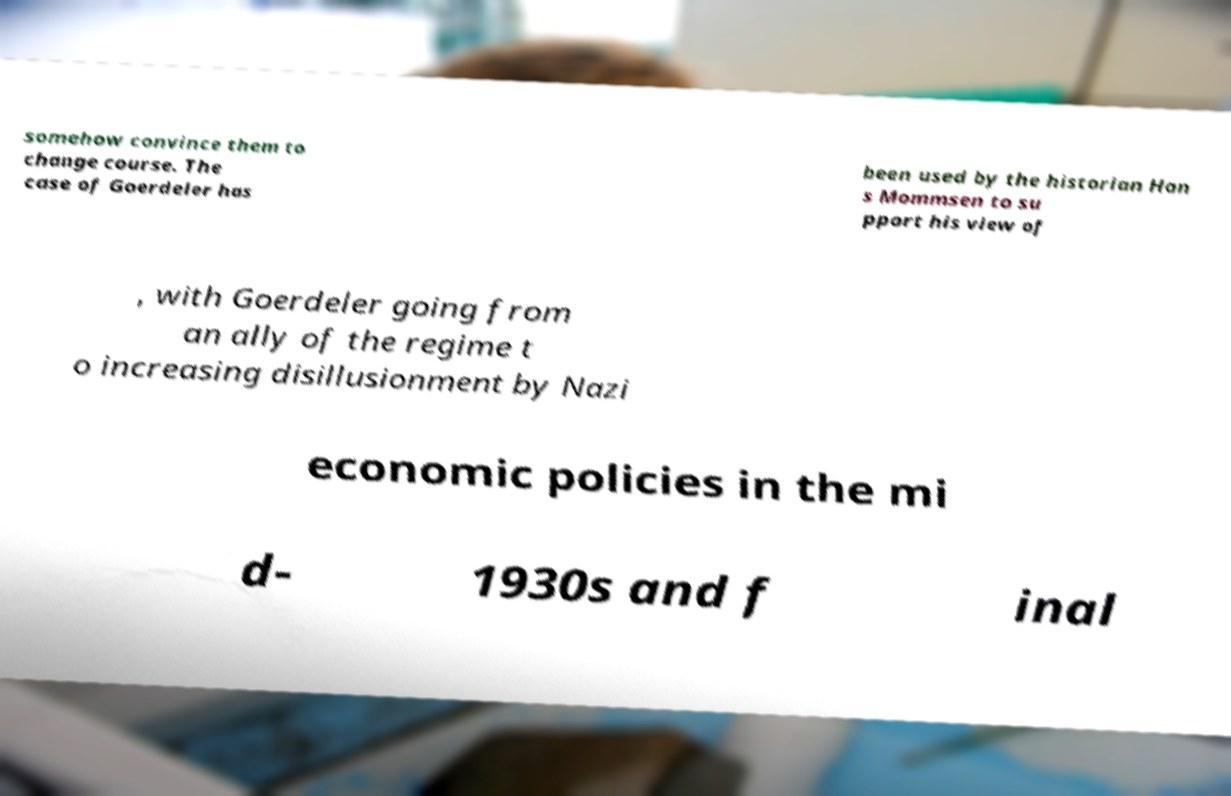Please read and relay the text visible in this image. What does it say? somehow convince them to change course. The case of Goerdeler has been used by the historian Han s Mommsen to su pport his view of , with Goerdeler going from an ally of the regime t o increasing disillusionment by Nazi economic policies in the mi d- 1930s and f inal 